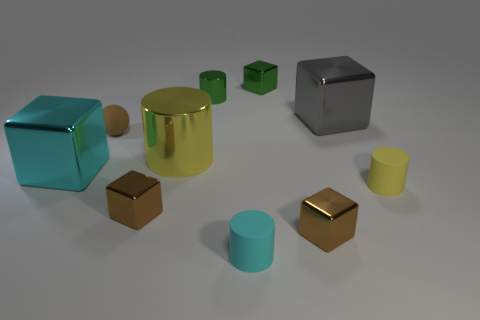Subtract all cyan rubber cylinders. How many cylinders are left? 3 Subtract all yellow cylinders. How many cylinders are left? 2 Subtract all green balls. How many yellow cylinders are left? 2 Subtract all tiny purple blocks. Subtract all small green shiny things. How many objects are left? 8 Add 7 rubber cylinders. How many rubber cylinders are left? 9 Add 4 rubber blocks. How many rubber blocks exist? 4 Subtract 1 cyan blocks. How many objects are left? 9 Subtract all cylinders. How many objects are left? 6 Subtract 1 spheres. How many spheres are left? 0 Subtract all cyan balls. Subtract all purple cubes. How many balls are left? 1 